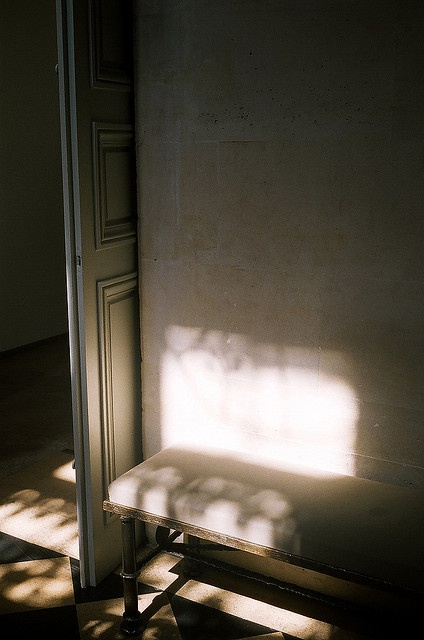Describe the objects in this image and their specific colors. I can see a bench in black, white, gray, and tan tones in this image. 